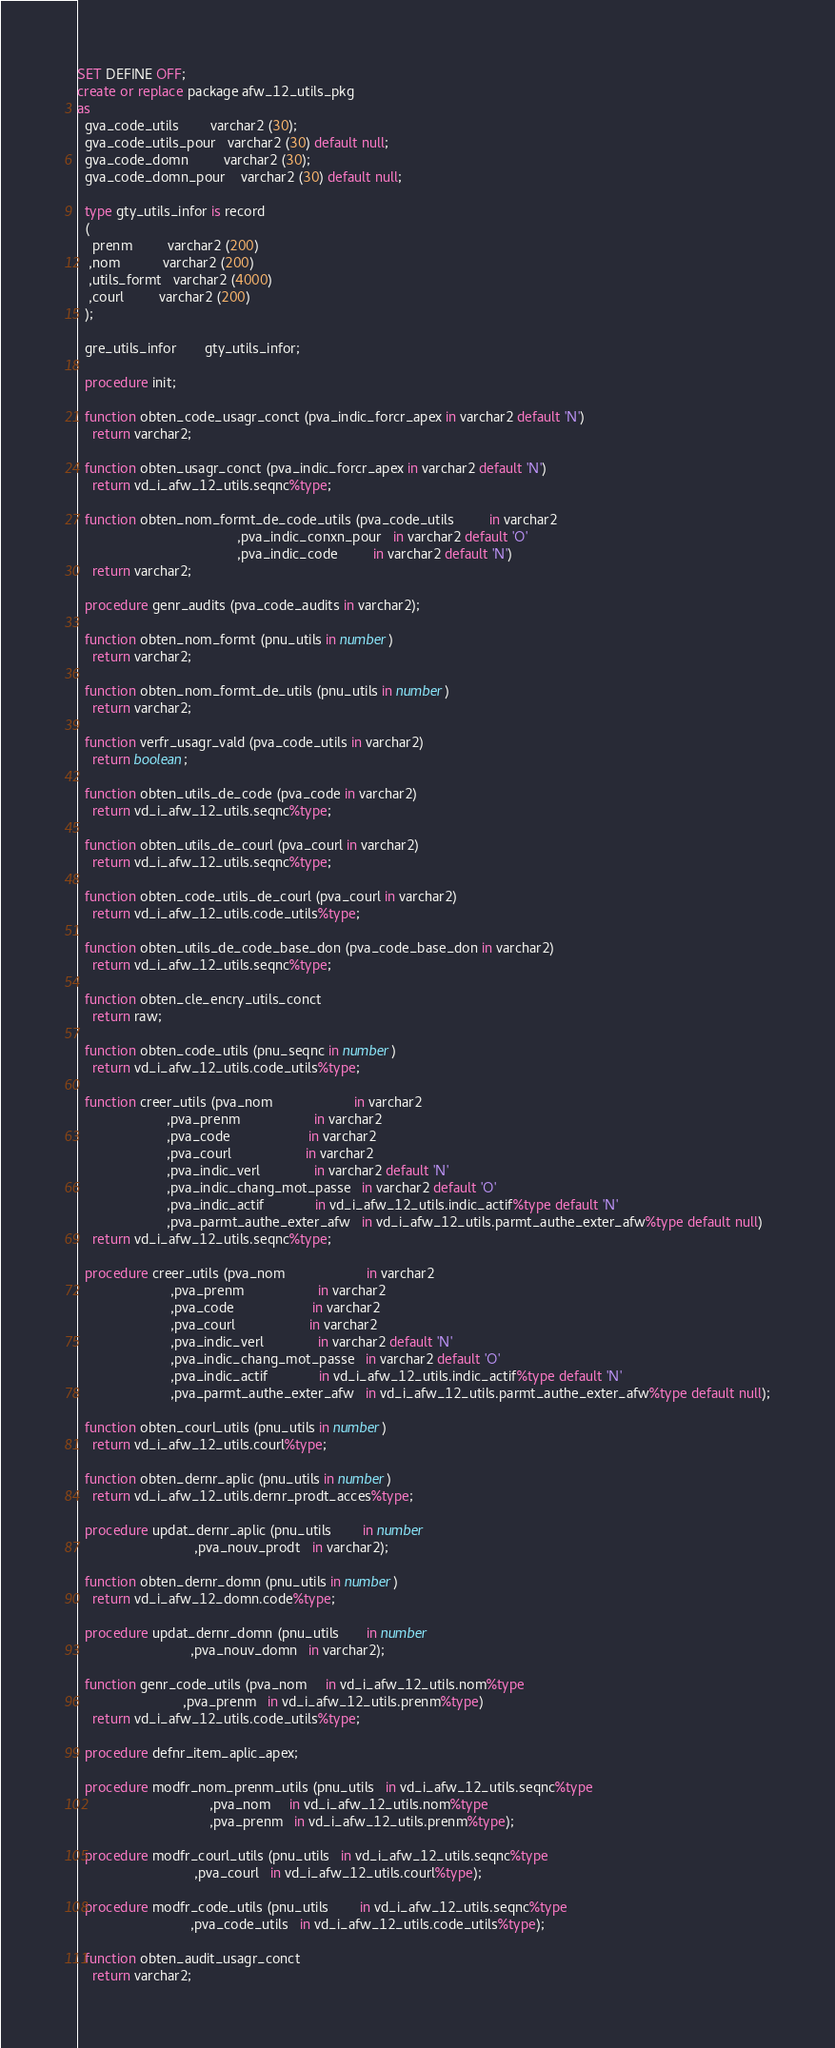<code> <loc_0><loc_0><loc_500><loc_500><_SQL_>SET DEFINE OFF;
create or replace package afw_12_utils_pkg
as
  gva_code_utils        varchar2 (30);
  gva_code_utils_pour   varchar2 (30) default null;
  gva_code_domn         varchar2 (30);
  gva_code_domn_pour    varchar2 (30) default null;

  type gty_utils_infor is record
  (
    prenm         varchar2 (200)
   ,nom           varchar2 (200)
   ,utils_formt   varchar2 (4000)
   ,courl         varchar2 (200)
  );

  gre_utils_infor       gty_utils_infor;

  procedure init;

  function obten_code_usagr_conct (pva_indic_forcr_apex in varchar2 default 'N')
    return varchar2;

  function obten_usagr_conct (pva_indic_forcr_apex in varchar2 default 'N')
    return vd_i_afw_12_utils.seqnc%type;

  function obten_nom_formt_de_code_utils (pva_code_utils         in varchar2
                                         ,pva_indic_conxn_pour   in varchar2 default 'O'
                                         ,pva_indic_code         in varchar2 default 'N')
    return varchar2;

  procedure genr_audits (pva_code_audits in varchar2);

  function obten_nom_formt (pnu_utils in number)
    return varchar2;

  function obten_nom_formt_de_utils (pnu_utils in number)
    return varchar2;

  function verfr_usagr_vald (pva_code_utils in varchar2)
    return boolean;

  function obten_utils_de_code (pva_code in varchar2)
    return vd_i_afw_12_utils.seqnc%type;

  function obten_utils_de_courl (pva_courl in varchar2)
    return vd_i_afw_12_utils.seqnc%type;

  function obten_code_utils_de_courl (pva_courl in varchar2)
    return vd_i_afw_12_utils.code_utils%type;

  function obten_utils_de_code_base_don (pva_code_base_don in varchar2)
    return vd_i_afw_12_utils.seqnc%type;

  function obten_cle_encry_utils_conct
    return raw;

  function obten_code_utils (pnu_seqnc in number)
    return vd_i_afw_12_utils.code_utils%type;

  function creer_utils (pva_nom                     in varchar2
                       ,pva_prenm                   in varchar2
                       ,pva_code                    in varchar2
                       ,pva_courl                   in varchar2
                       ,pva_indic_verl              in varchar2 default 'N'
                       ,pva_indic_chang_mot_passe   in varchar2 default 'O'
                       ,pva_indic_actif             in vd_i_afw_12_utils.indic_actif%type default 'N'
                       ,pva_parmt_authe_exter_afw   in vd_i_afw_12_utils.parmt_authe_exter_afw%type default null)
    return vd_i_afw_12_utils.seqnc%type;

  procedure creer_utils (pva_nom                     in varchar2
                        ,pva_prenm                   in varchar2
                        ,pva_code                    in varchar2
                        ,pva_courl                   in varchar2
                        ,pva_indic_verl              in varchar2 default 'N'
                        ,pva_indic_chang_mot_passe   in varchar2 default 'O'
                        ,pva_indic_actif             in vd_i_afw_12_utils.indic_actif%type default 'N'
                        ,pva_parmt_authe_exter_afw   in vd_i_afw_12_utils.parmt_authe_exter_afw%type default null);

  function obten_courl_utils (pnu_utils in number)
    return vd_i_afw_12_utils.courl%type;

  function obten_dernr_aplic (pnu_utils in number)
    return vd_i_afw_12_utils.dernr_prodt_acces%type;

  procedure updat_dernr_aplic (pnu_utils        in number
                              ,pva_nouv_prodt   in varchar2);

  function obten_dernr_domn (pnu_utils in number)
    return vd_i_afw_12_domn.code%type;

  procedure updat_dernr_domn (pnu_utils       in number
                             ,pva_nouv_domn   in varchar2);

  function genr_code_utils (pva_nom     in vd_i_afw_12_utils.nom%type
                           ,pva_prenm   in vd_i_afw_12_utils.prenm%type)
    return vd_i_afw_12_utils.code_utils%type;

  procedure defnr_item_aplic_apex;

  procedure modfr_nom_prenm_utils (pnu_utils   in vd_i_afw_12_utils.seqnc%type
                                  ,pva_nom     in vd_i_afw_12_utils.nom%type
                                  ,pva_prenm   in vd_i_afw_12_utils.prenm%type);

  procedure modfr_courl_utils (pnu_utils   in vd_i_afw_12_utils.seqnc%type
                              ,pva_courl   in vd_i_afw_12_utils.courl%type);

  procedure modfr_code_utils (pnu_utils        in vd_i_afw_12_utils.seqnc%type
                             ,pva_code_utils   in vd_i_afw_12_utils.code_utils%type);

  function obten_audit_usagr_conct
    return varchar2;
</code> 